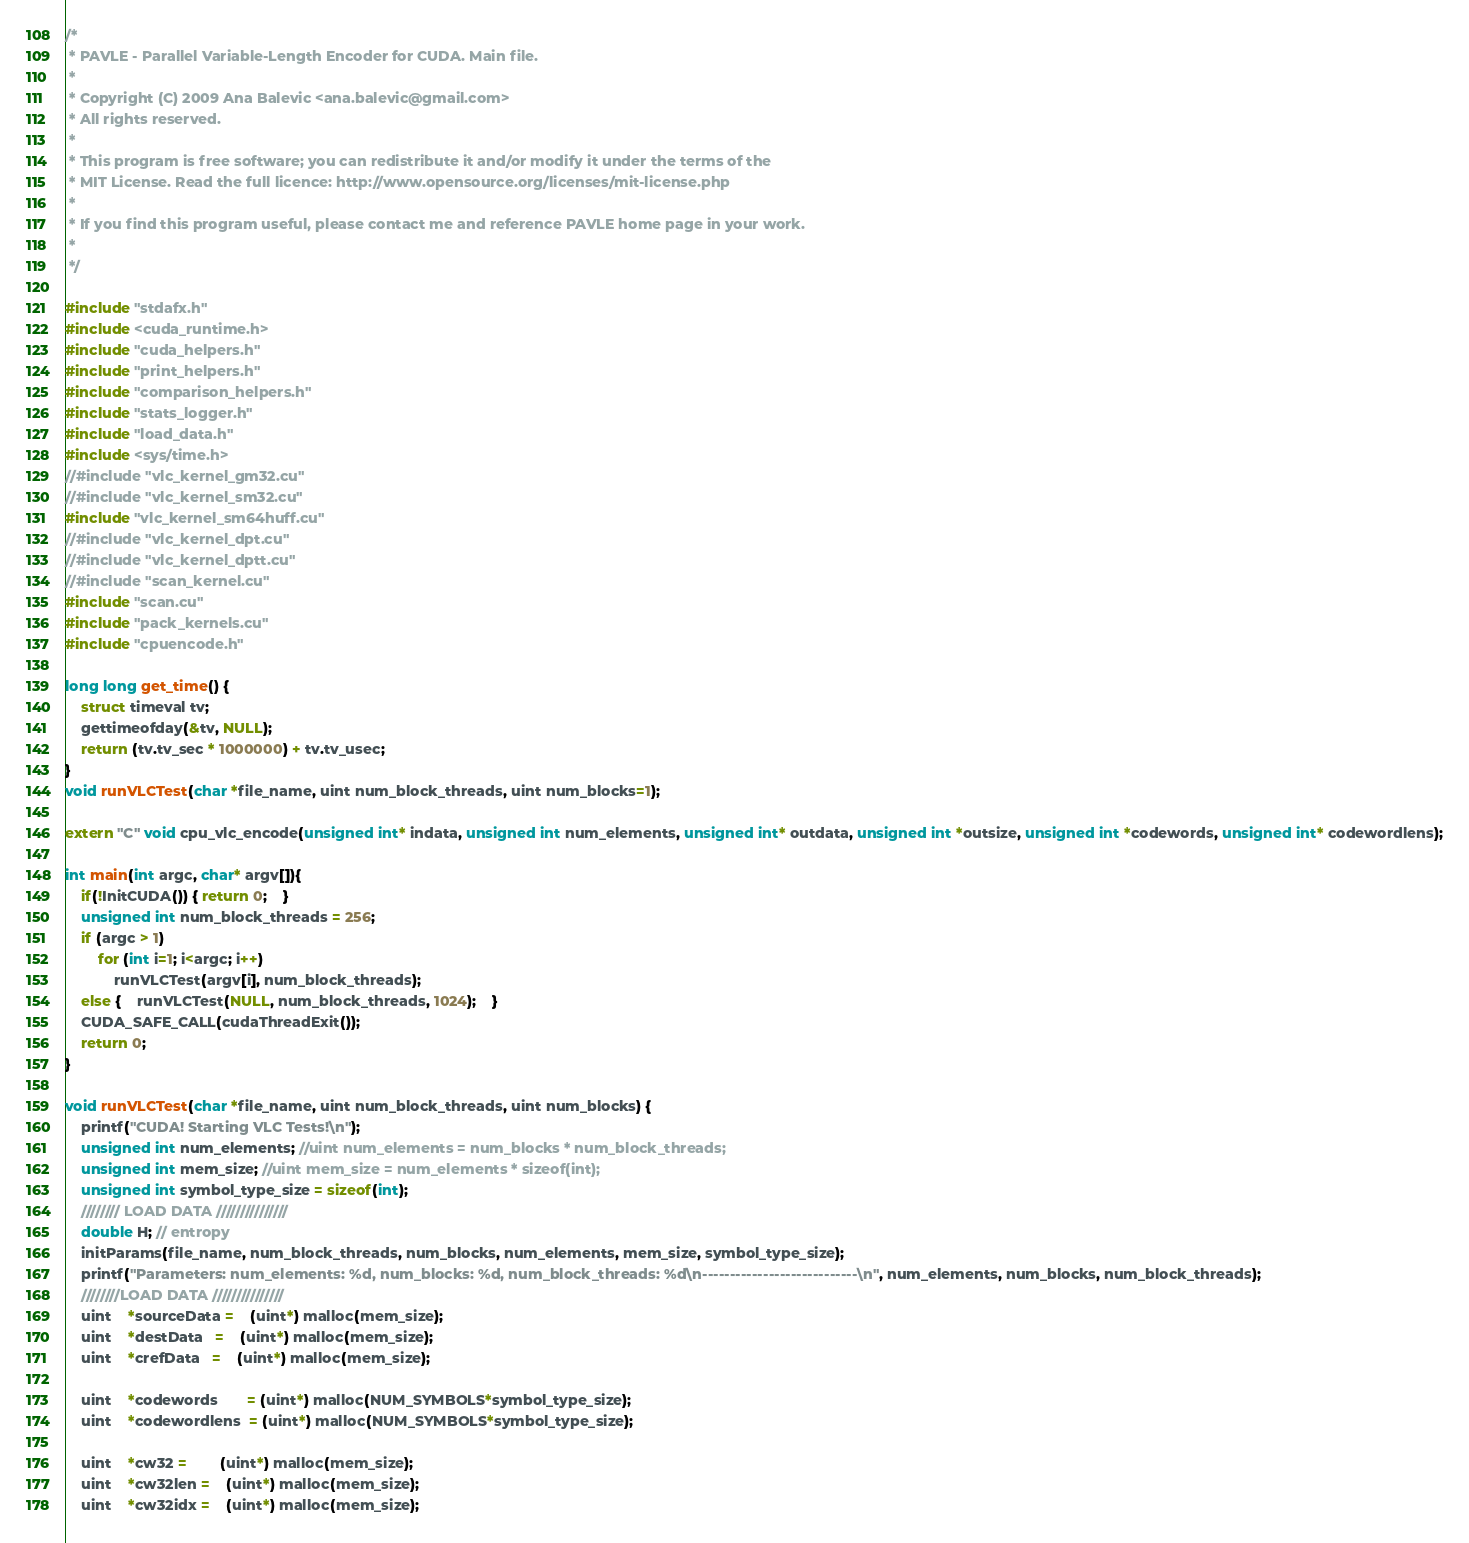Convert code to text. <code><loc_0><loc_0><loc_500><loc_500><_Cuda_>/*
 * PAVLE - Parallel Variable-Length Encoder for CUDA. Main file.
 *
 * Copyright (C) 2009 Ana Balevic <ana.balevic@gmail.com>
 * All rights reserved.
 *
 * This program is free software; you can redistribute it and/or modify it under the terms of the
 * MIT License. Read the full licence: http://www.opensource.org/licenses/mit-license.php
 *
 * If you find this program useful, please contact me and reference PAVLE home page in your work.
 * 
 */

#include "stdafx.h"
#include <cuda_runtime.h>
#include "cuda_helpers.h"
#include "print_helpers.h"
#include "comparison_helpers.h"
#include "stats_logger.h"
#include "load_data.h"
#include <sys/time.h>
//#include "vlc_kernel_gm32.cu"
//#include "vlc_kernel_sm32.cu"
#include "vlc_kernel_sm64huff.cu"
//#include "vlc_kernel_dpt.cu"
//#include "vlc_kernel_dptt.cu"
//#include "scan_kernel.cu"
#include "scan.cu"
#include "pack_kernels.cu"
#include "cpuencode.h"

long long get_time() {
	struct timeval tv;
	gettimeofday(&tv, NULL);
	return (tv.tv_sec * 1000000) + tv.tv_usec;
}
void runVLCTest(char *file_name, uint num_block_threads, uint num_blocks=1);

extern "C" void cpu_vlc_encode(unsigned int* indata, unsigned int num_elements, unsigned int* outdata, unsigned int *outsize, unsigned int *codewords, unsigned int* codewordlens);

int main(int argc, char* argv[]){
    if(!InitCUDA()) { return 0;	}
    unsigned int num_block_threads = 256;
    if (argc > 1)
        for (int i=1; i<argc; i++)
            runVLCTest(argv[i], num_block_threads);
    else {	runVLCTest(NULL, num_block_threads, 1024);	}
    CUDA_SAFE_CALL(cudaThreadExit());
    return 0;
}

void runVLCTest(char *file_name, uint num_block_threads, uint num_blocks) {
    printf("CUDA! Starting VLC Tests!\n");
    unsigned int num_elements; //uint num_elements = num_blocks * num_block_threads; 
    unsigned int mem_size; //uint mem_size = num_elements * sizeof(int); 
    unsigned int symbol_type_size = sizeof(int);
    //////// LOAD DATA ///////////////
    double H; // entropy
    initParams(file_name, num_block_threads, num_blocks, num_elements, mem_size, symbol_type_size);
    printf("Parameters: num_elements: %d, num_blocks: %d, num_block_threads: %d\n----------------------------\n", num_elements, num_blocks, num_block_threads);
    ////////LOAD DATA ///////////////
    uint	*sourceData =	(uint*) malloc(mem_size);
    uint	*destData   =	(uint*) malloc(mem_size);
    uint	*crefData   =	(uint*) malloc(mem_size);

    uint	*codewords	   = (uint*) malloc(NUM_SYMBOLS*symbol_type_size);
    uint	*codewordlens  = (uint*) malloc(NUM_SYMBOLS*symbol_type_size);

    uint	*cw32 =		(uint*) malloc(mem_size);
    uint	*cw32len =	(uint*) malloc(mem_size);
    uint	*cw32idx =	(uint*) malloc(mem_size);
</code> 